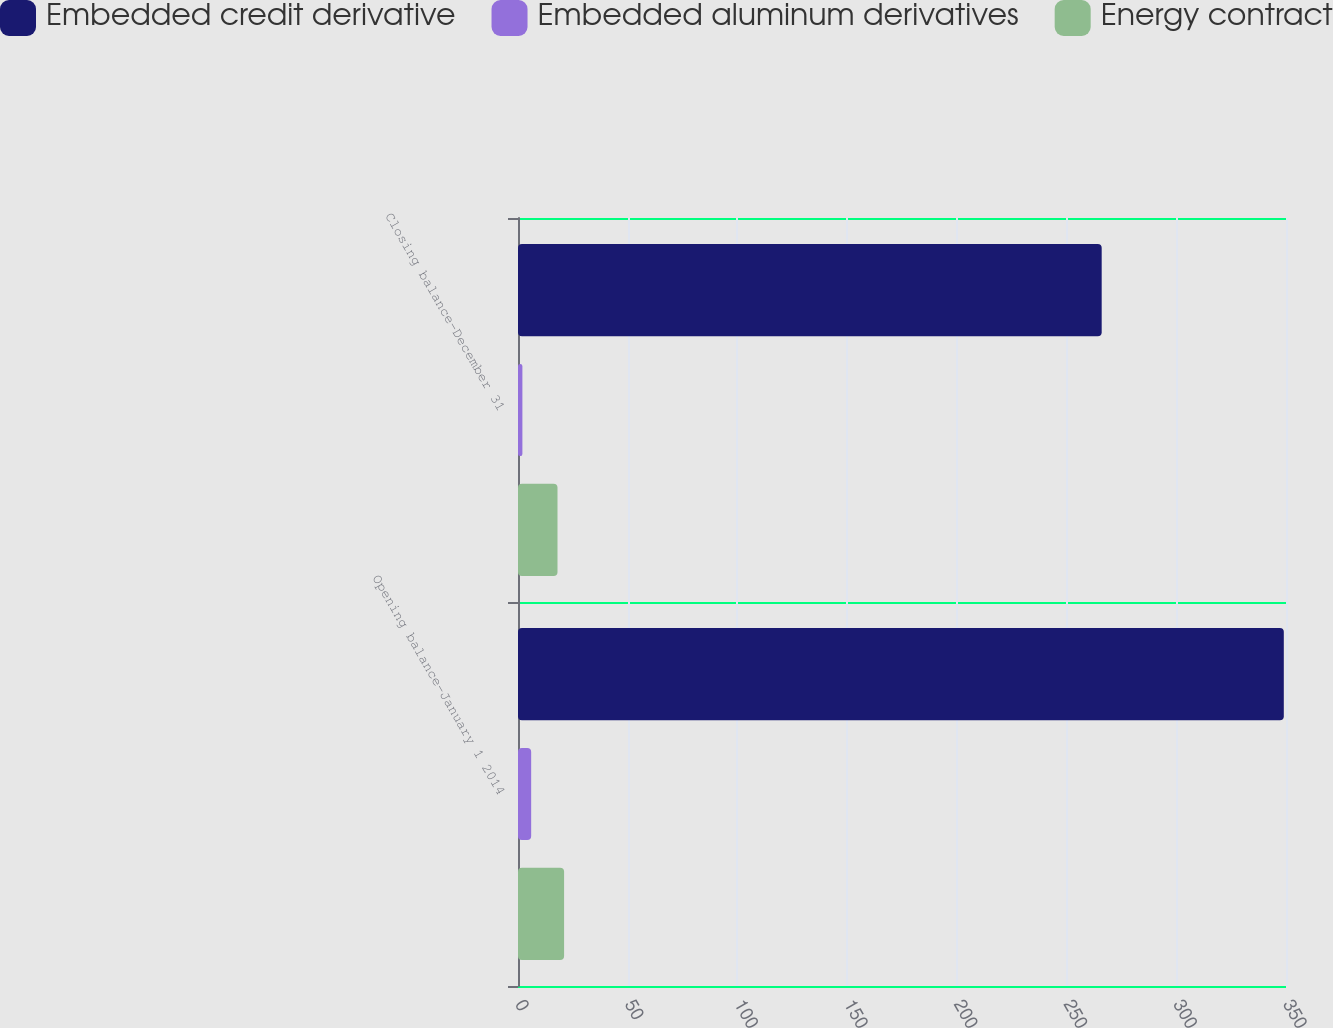Convert chart to OTSL. <chart><loc_0><loc_0><loc_500><loc_500><stacked_bar_chart><ecel><fcel>Opening balance-January 1 2014<fcel>Closing balance-December 31<nl><fcel>Embedded credit derivative<fcel>349<fcel>266<nl><fcel>Embedded aluminum derivatives<fcel>6<fcel>2<nl><fcel>Energy contract<fcel>21<fcel>18<nl></chart> 